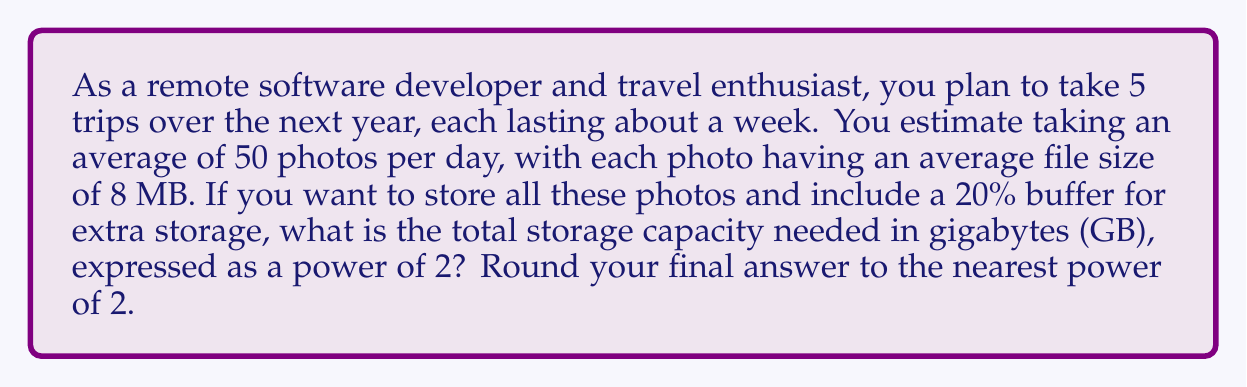Give your solution to this math problem. Let's break this down step-by-step:

1. Calculate the total number of photos:
   - Number of trips: 5
   - Days per trip: 7
   - Photos per day: 50
   Total photos = $5 \times 7 \times 50 = 1,750$ photos

2. Calculate the total storage needed for photos:
   - Each photo is 8 MB
   Total storage = $1,750 \times 8 \text{ MB} = 14,000 \text{ MB}$

3. Convert MB to GB:
   $14,000 \text{ MB} = 14,000 \div 1,024 \text{ GB} \approx 13.67 \text{ GB}$

4. Add 20% buffer:
   $13.67 \text{ GB} \times 1.2 = 16.40 \text{ GB}$

5. Express as a power of 2:
   The nearest power of 2 greater than 16.40 GB is $2^4 = 16 \text{ GB}$

Therefore, the storage capacity needed, expressed as a power of 2, is $2^4$ GB.
Answer: $2^4$ GB 